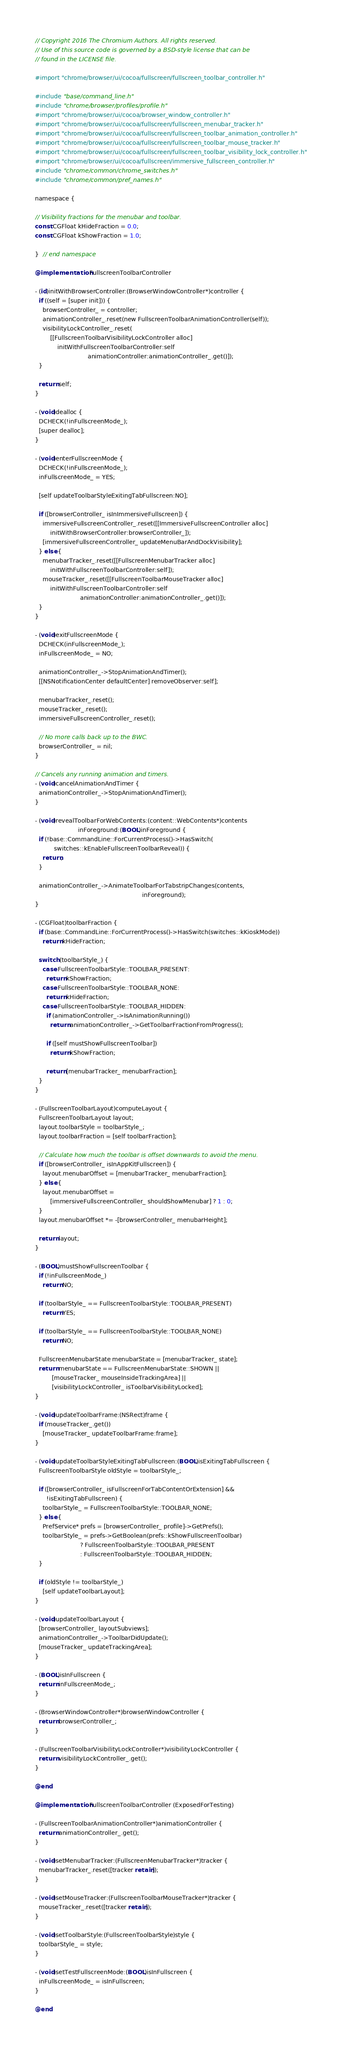Convert code to text. <code><loc_0><loc_0><loc_500><loc_500><_ObjectiveC_>// Copyright 2016 The Chromium Authors. All rights reserved.
// Use of this source code is governed by a BSD-style license that can be
// found in the LICENSE file.

#import "chrome/browser/ui/cocoa/fullscreen/fullscreen_toolbar_controller.h"

#include "base/command_line.h"
#include "chrome/browser/profiles/profile.h"
#import "chrome/browser/ui/cocoa/browser_window_controller.h"
#import "chrome/browser/ui/cocoa/fullscreen/fullscreen_menubar_tracker.h"
#import "chrome/browser/ui/cocoa/fullscreen/fullscreen_toolbar_animation_controller.h"
#import "chrome/browser/ui/cocoa/fullscreen/fullscreen_toolbar_mouse_tracker.h"
#import "chrome/browser/ui/cocoa/fullscreen/fullscreen_toolbar_visibility_lock_controller.h"
#import "chrome/browser/ui/cocoa/fullscreen/immersive_fullscreen_controller.h"
#include "chrome/common/chrome_switches.h"
#include "chrome/common/pref_names.h"

namespace {

// Visibility fractions for the menubar and toolbar.
const CGFloat kHideFraction = 0.0;
const CGFloat kShowFraction = 1.0;

}  // end namespace

@implementation FullscreenToolbarController

- (id)initWithBrowserController:(BrowserWindowController*)controller {
  if ((self = [super init])) {
    browserController_ = controller;
    animationController_.reset(new FullscreenToolbarAnimationController(self));
    visibilityLockController_.reset(
        [[FullscreenToolbarVisibilityLockController alloc]
            initWithFullscreenToolbarController:self
                            animationController:animationController_.get()]);
  }

  return self;
}

- (void)dealloc {
  DCHECK(!inFullscreenMode_);
  [super dealloc];
}

- (void)enterFullscreenMode {
  DCHECK(!inFullscreenMode_);
  inFullscreenMode_ = YES;

  [self updateToolbarStyleExitingTabFullscreen:NO];

  if ([browserController_ isInImmersiveFullscreen]) {
    immersiveFullscreenController_.reset([[ImmersiveFullscreenController alloc]
        initWithBrowserController:browserController_]);
    [immersiveFullscreenController_ updateMenuBarAndDockVisibility];
  } else {
    menubarTracker_.reset([[FullscreenMenubarTracker alloc]
        initWithFullscreenToolbarController:self]);
    mouseTracker_.reset([[FullscreenToolbarMouseTracker alloc]
        initWithFullscreenToolbarController:self
                        animationController:animationController_.get()]);
  }
}

- (void)exitFullscreenMode {
  DCHECK(inFullscreenMode_);
  inFullscreenMode_ = NO;

  animationController_->StopAnimationAndTimer();
  [[NSNotificationCenter defaultCenter] removeObserver:self];

  menubarTracker_.reset();
  mouseTracker_.reset();
  immersiveFullscreenController_.reset();

  // No more calls back up to the BWC.
  browserController_ = nil;
}

// Cancels any running animation and timers.
- (void)cancelAnimationAndTimer {
  animationController_->StopAnimationAndTimer();
}

- (void)revealToolbarForWebContents:(content::WebContents*)contents
                       inForeground:(BOOL)inForeground {
  if (!base::CommandLine::ForCurrentProcess()->HasSwitch(
          switches::kEnableFullscreenToolbarReveal)) {
    return;
  }

  animationController_->AnimateToolbarForTabstripChanges(contents,
                                                         inForeground);
}

- (CGFloat)toolbarFraction {
  if (base::CommandLine::ForCurrentProcess()->HasSwitch(switches::kKioskMode))
    return kHideFraction;

  switch (toolbarStyle_) {
    case FullscreenToolbarStyle::TOOLBAR_PRESENT:
      return kShowFraction;
    case FullscreenToolbarStyle::TOOLBAR_NONE:
      return kHideFraction;
    case FullscreenToolbarStyle::TOOLBAR_HIDDEN:
      if (animationController_->IsAnimationRunning())
        return animationController_->GetToolbarFractionFromProgress();

      if ([self mustShowFullscreenToolbar])
        return kShowFraction;

      return [menubarTracker_ menubarFraction];
  }
}

- (FullscreenToolbarLayout)computeLayout {
  FullscreenToolbarLayout layout;
  layout.toolbarStyle = toolbarStyle_;
  layout.toolbarFraction = [self toolbarFraction];

  // Calculate how much the toolbar is offset downwards to avoid the menu.
  if ([browserController_ isInAppKitFullscreen]) {
    layout.menubarOffset = [menubarTracker_ menubarFraction];
  } else {
    layout.menubarOffset =
        [immersiveFullscreenController_ shouldShowMenubar] ? 1 : 0;
  }
  layout.menubarOffset *= -[browserController_ menubarHeight];

  return layout;
}

- (BOOL)mustShowFullscreenToolbar {
  if (!inFullscreenMode_)
    return NO;

  if (toolbarStyle_ == FullscreenToolbarStyle::TOOLBAR_PRESENT)
    return YES;

  if (toolbarStyle_ == FullscreenToolbarStyle::TOOLBAR_NONE)
    return NO;

  FullscreenMenubarState menubarState = [menubarTracker_ state];
  return menubarState == FullscreenMenubarState::SHOWN ||
         [mouseTracker_ mouseInsideTrackingArea] ||
         [visibilityLockController_ isToolbarVisibilityLocked];
}

- (void)updateToolbarFrame:(NSRect)frame {
  if (mouseTracker_.get())
    [mouseTracker_ updateToolbarFrame:frame];
}

- (void)updateToolbarStyleExitingTabFullscreen:(BOOL)isExitingTabFullscreen {
  FullscreenToolbarStyle oldStyle = toolbarStyle_;

  if ([browserController_ isFullscreenForTabContentOrExtension] &&
      !isExitingTabFullscreen) {
    toolbarStyle_ = FullscreenToolbarStyle::TOOLBAR_NONE;
  } else {
    PrefService* prefs = [browserController_ profile]->GetPrefs();
    toolbarStyle_ = prefs->GetBoolean(prefs::kShowFullscreenToolbar)
                        ? FullscreenToolbarStyle::TOOLBAR_PRESENT
                        : FullscreenToolbarStyle::TOOLBAR_HIDDEN;
  }

  if (oldStyle != toolbarStyle_)
    [self updateToolbarLayout];
}

- (void)updateToolbarLayout {
  [browserController_ layoutSubviews];
  animationController_->ToolbarDidUpdate();
  [mouseTracker_ updateTrackingArea];
}

- (BOOL)isInFullscreen {
  return inFullscreenMode_;
}

- (BrowserWindowController*)browserWindowController {
  return browserController_;
}

- (FullscreenToolbarVisibilityLockController*)visibilityLockController {
  return visibilityLockController_.get();
}

@end

@implementation FullscreenToolbarController (ExposedForTesting)

- (FullscreenToolbarAnimationController*)animationController {
  return animationController_.get();
}

- (void)setMenubarTracker:(FullscreenMenubarTracker*)tracker {
  menubarTracker_.reset([tracker retain]);
}

- (void)setMouseTracker:(FullscreenToolbarMouseTracker*)tracker {
  mouseTracker_.reset([tracker retain]);
}

- (void)setToolbarStyle:(FullscreenToolbarStyle)style {
  toolbarStyle_ = style;
}

- (void)setTestFullscreenMode:(BOOL)isInFullscreen {
  inFullscreenMode_ = isInFullscreen;
}

@end
</code> 